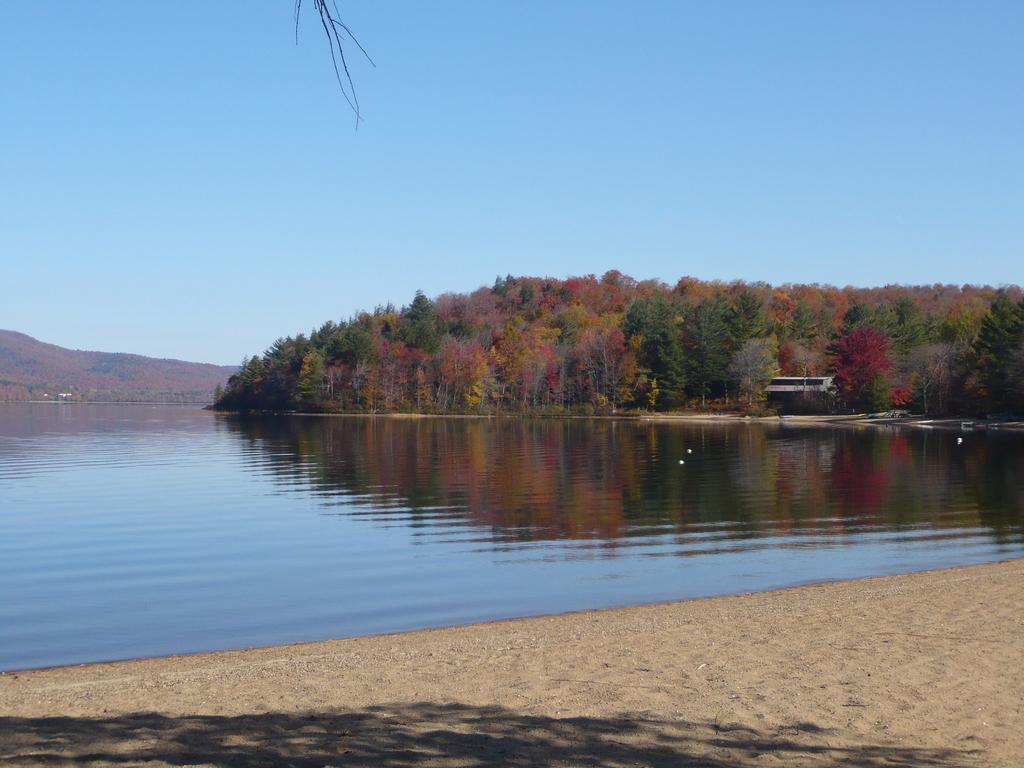Describe this image in one or two sentences. In this image I can see a river at the back there are so many trees and mountain. 